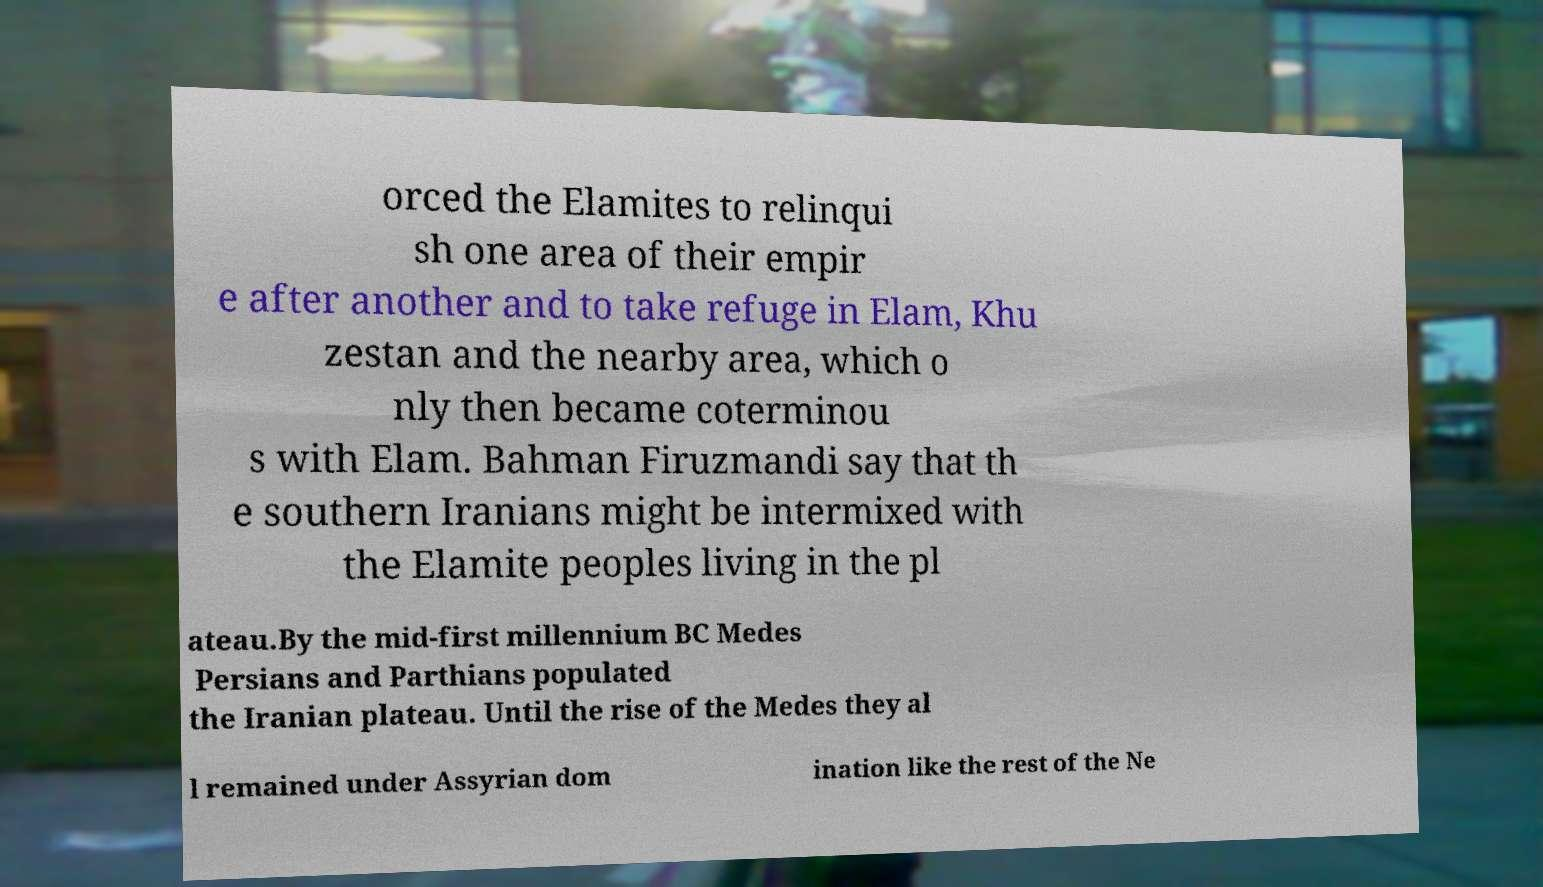For documentation purposes, I need the text within this image transcribed. Could you provide that? orced the Elamites to relinqui sh one area of their empir e after another and to take refuge in Elam, Khu zestan and the nearby area, which o nly then became coterminou s with Elam. Bahman Firuzmandi say that th e southern Iranians might be intermixed with the Elamite peoples living in the pl ateau.By the mid-first millennium BC Medes Persians and Parthians populated the Iranian plateau. Until the rise of the Medes they al l remained under Assyrian dom ination like the rest of the Ne 